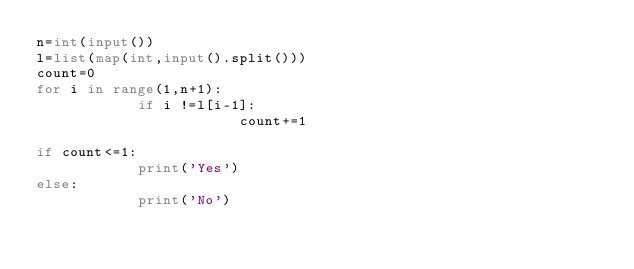<code> <loc_0><loc_0><loc_500><loc_500><_Python_>n=int(input())
l=list(map(int,input().split()))
count=0
for i in range(1,n+1):
            if i !=l[i-1]:
                        count+=1
                     
if count<=1:
            print('Yes')
else:
            print('No')
            
                                    
                                    
                                    
</code> 